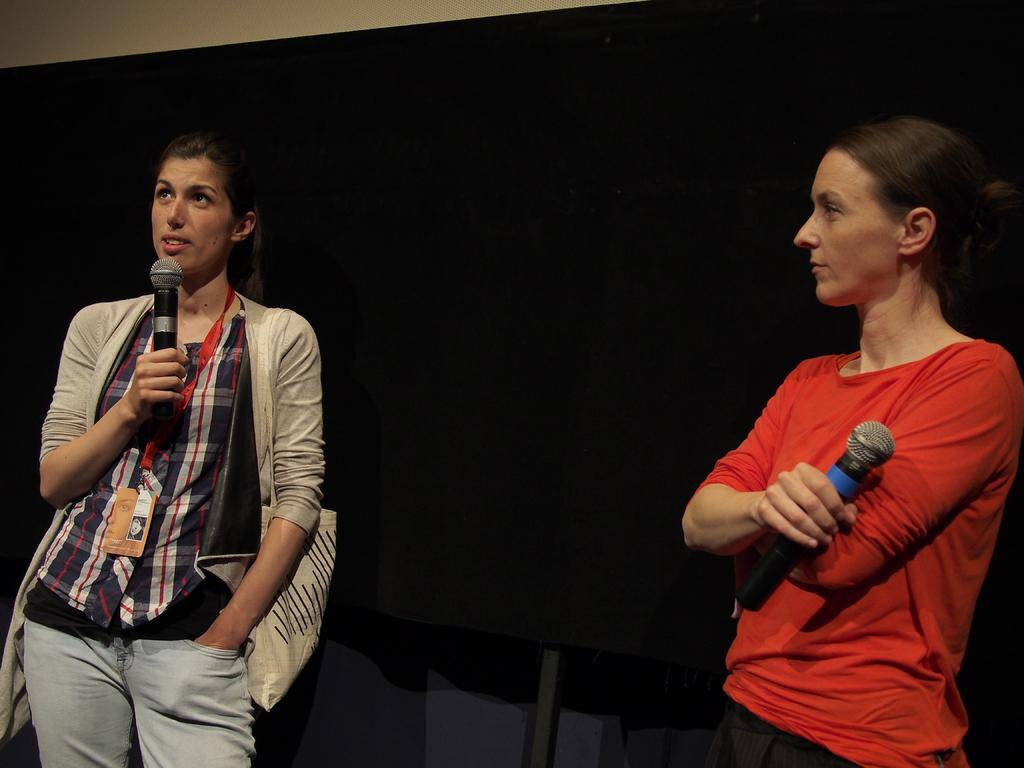How many people are in the image? There are two women in the image. What are the women doing in the image? The women are standing and holding a microphone. What type of pin can be seen on the ground in the image? There is no pin present on the ground in the image. Where is the camp located in the image? There is no camp present in the image. 